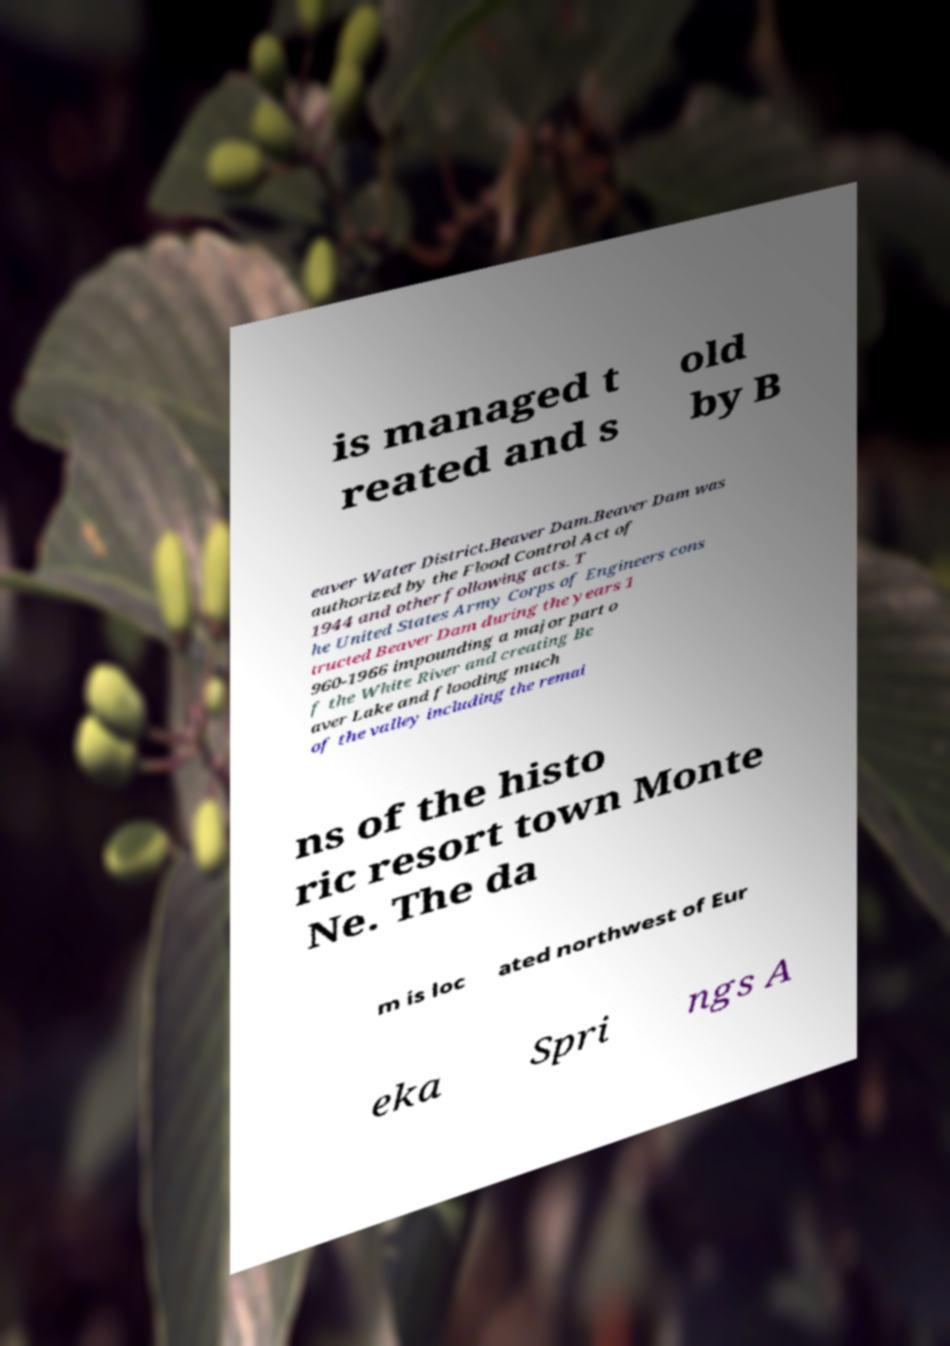Please read and relay the text visible in this image. What does it say? is managed t reated and s old by B eaver Water District.Beaver Dam.Beaver Dam was authorized by the Flood Control Act of 1944 and other following acts. T he United States Army Corps of Engineers cons tructed Beaver Dam during the years 1 960-1966 impounding a major part o f the White River and creating Be aver Lake and flooding much of the valley including the remai ns of the histo ric resort town Monte Ne. The da m is loc ated northwest of Eur eka Spri ngs A 